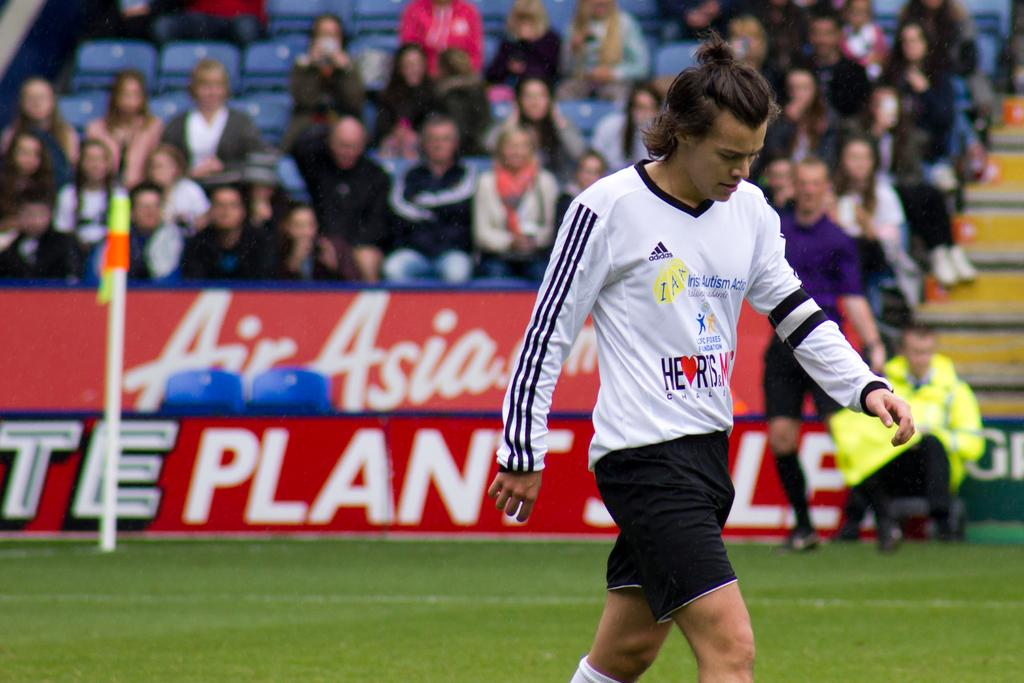What is the main subject of the image? The main subject of the image is a player. What is the player wearing? The player is wearing a white t-shirt and black shorts. What is the player doing in the image? The player is walking in the ground. What can be seen in the background of the image? There is a stadium in the background of the image. What is inside the stadium? There are seats in the stadium. Who is occupying the seats? Audience members are sitting in the seats. How are the audience members feeling during the game? The audience is enjoying the game. What scientific discovery was made by the player in the image? There is no mention of a scientific discovery in the image; it simply shows a player walking in the ground. 